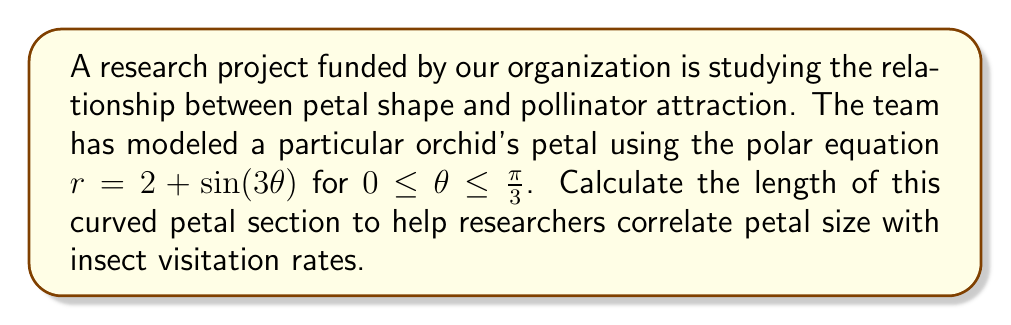Help me with this question. To find the length of a curve in polar coordinates, we use the arc length formula:

$$L = \int_{a}^{b} \sqrt{r^2 + \left(\frac{dr}{d\theta}\right)^2} d\theta$$

where $r$ is the polar function and $\frac{dr}{d\theta}$ is its derivative.

1) First, let's find $\frac{dr}{d\theta}$:
   $r = 2 + \sin(3\theta)$
   $\frac{dr}{d\theta} = 3\cos(3\theta)$

2) Now, let's substitute these into the arc length formula:
   $$L = \int_{0}^{\frac{\pi}{3}} \sqrt{(2 + \sin(3\theta))^2 + (3\cos(3\theta))^2} d\theta$$

3) Expand the expression under the square root:
   $$L = \int_{0}^{\frac{\pi}{3}} \sqrt{4 + 4\sin(3\theta) + \sin^2(3\theta) + 9\cos^2(3\theta)} d\theta$$

4) Simplify using the trigonometric identity $\sin^2(x) + \cos^2(x) = 1$:
   $$L = \int_{0}^{\frac{\pi}{3}} \sqrt{4 + 4\sin(3\theta) + 9 - 8\sin^2(3\theta)} d\theta$$
   $$L = \int_{0}^{\frac{\pi}{3}} \sqrt{13 + 4\sin(3\theta) - 8\sin^2(3\theta)} d\theta$$

5) This integral cannot be evaluated analytically and requires numerical integration methods to solve.

6) Using a numerical integration tool or computer algebra system, we can evaluate this integral to get the approximate length of the petal.
Answer: The length of the curved petal section is approximately 2.415 units. 